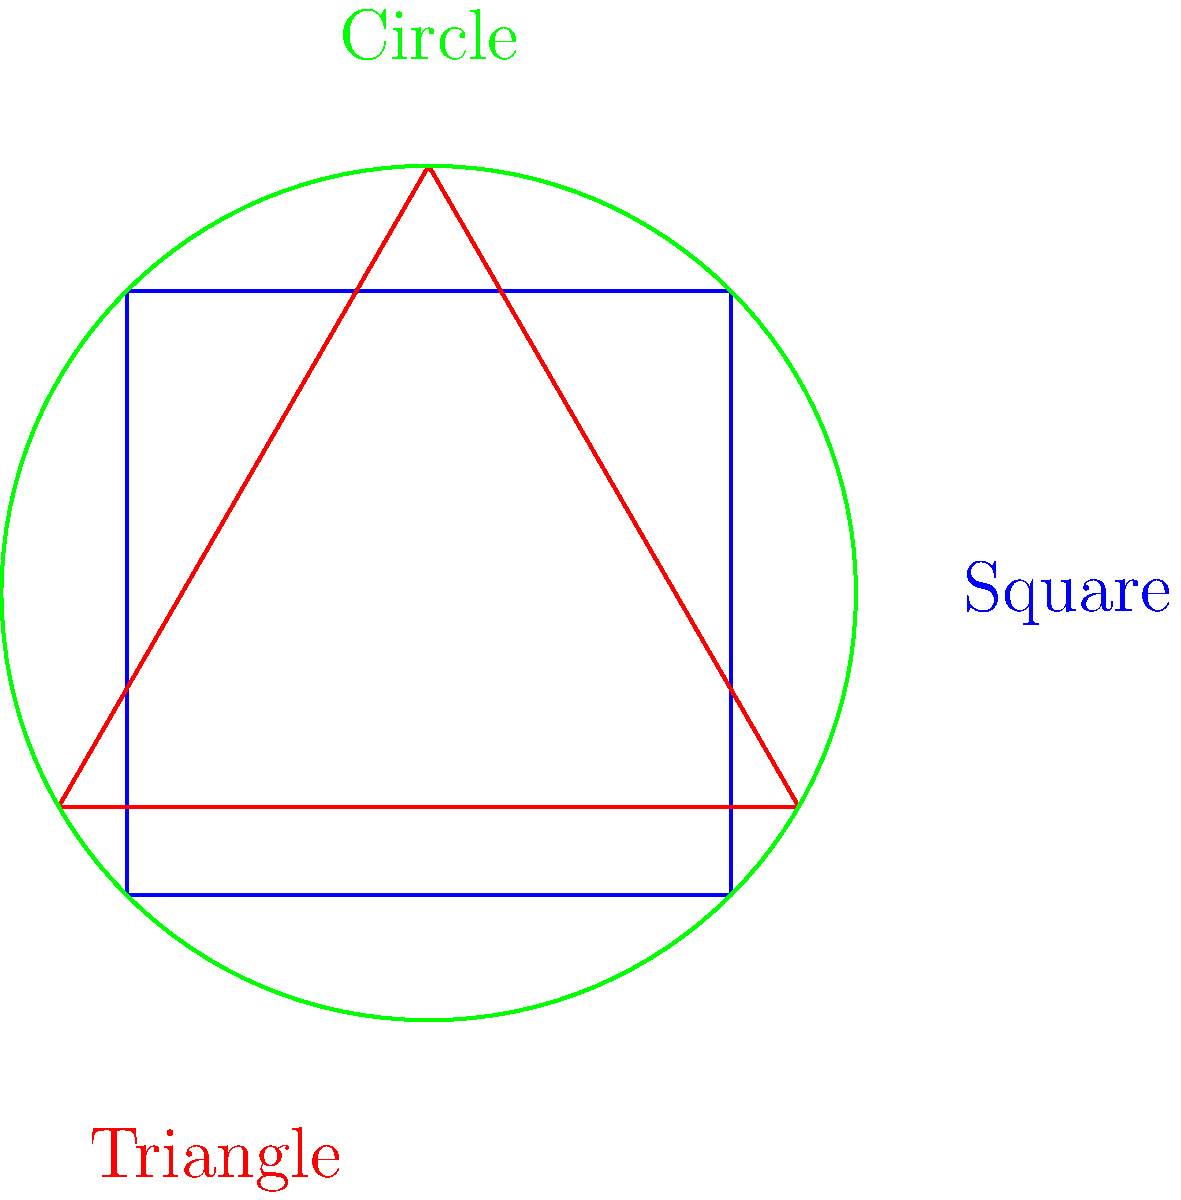In Coptic textile designs, geometric patterns often incorporate basic shapes. Which of the three shapes shown in the diagram is most commonly used as a repeated motif in Coptic textiles, particularly in border designs? To answer this question, we need to consider the historical and cultural context of Coptic textile designs:

1. Coptic textiles are known for their intricate geometric patterns, often incorporating symbolic and decorative elements.

2. The square shape is frequently used in Coptic designs, but it's more often seen as a background grid or framework for other patterns.

3. The circle, while present in some designs, is less common as a repeated motif in Coptic textiles.

4. The triangle, however, is particularly significant in Coptic textile designs:
   a) Triangles are often used as repeated motifs in border designs.
   b) They can be arranged to create complex patterns, such as stars or diamonds.
   c) The triangle has symbolic significance in Coptic Christianity, often representing the Holy Trinity.

5. In border designs specifically, triangles are frequently used in repetitive patterns, creating a rhythm and continuity along the edges of textiles.

6. The versatility of the triangle allows for various arrangements and combinations, making it a popular choice for Coptic artisans.

Therefore, among the three basic shapes shown, the triangle is most commonly used as a repeated motif in Coptic textile designs, especially in border patterns.
Answer: Triangle 